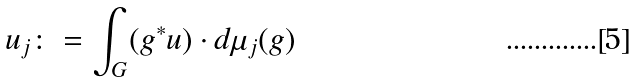<formula> <loc_0><loc_0><loc_500><loc_500>u _ { j } \colon = \int _ { G } ( g ^ { * } u ) \cdot d \mu _ { j } ( g )</formula> 